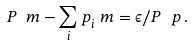Convert formula to latex. <formula><loc_0><loc_0><loc_500><loc_500>P ^ { \ } m - \sum _ { i } p _ { i } ^ { \ } m = \epsilon / P ^ { \ } p \, .</formula> 